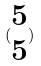<formula> <loc_0><loc_0><loc_500><loc_500>( \begin{matrix} 5 \\ 5 \end{matrix} )</formula> 